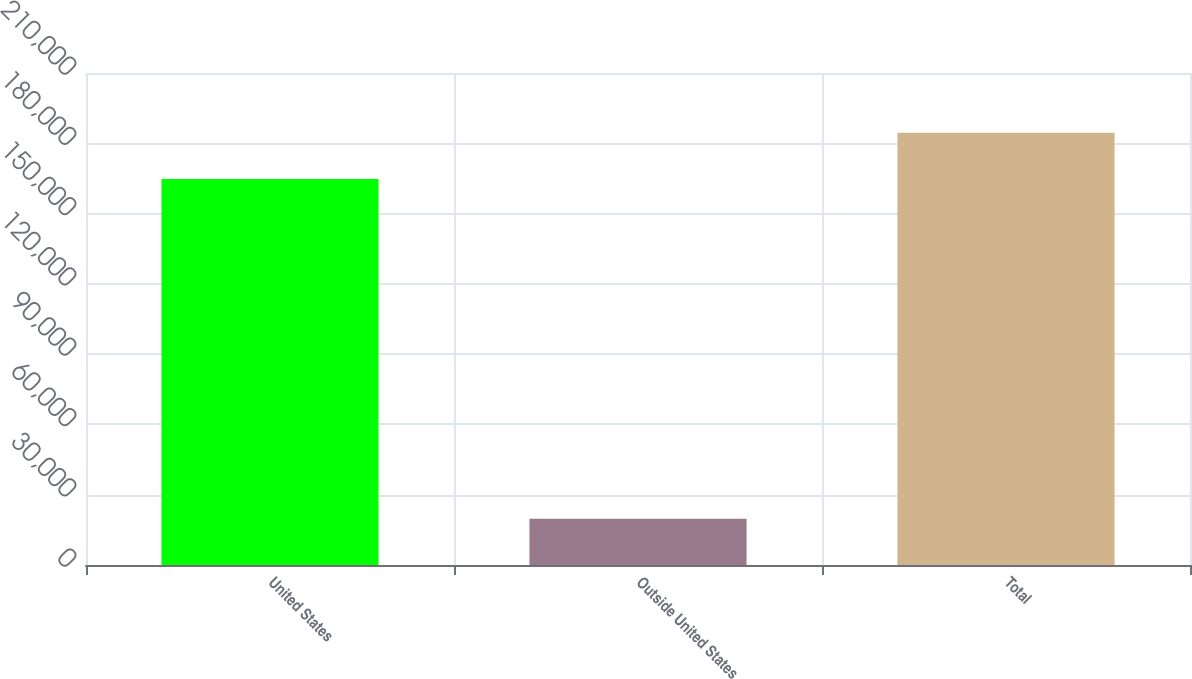<chart> <loc_0><loc_0><loc_500><loc_500><bar_chart><fcel>United States<fcel>Outside United States<fcel>Total<nl><fcel>164784<fcel>19764<fcel>184548<nl></chart> 